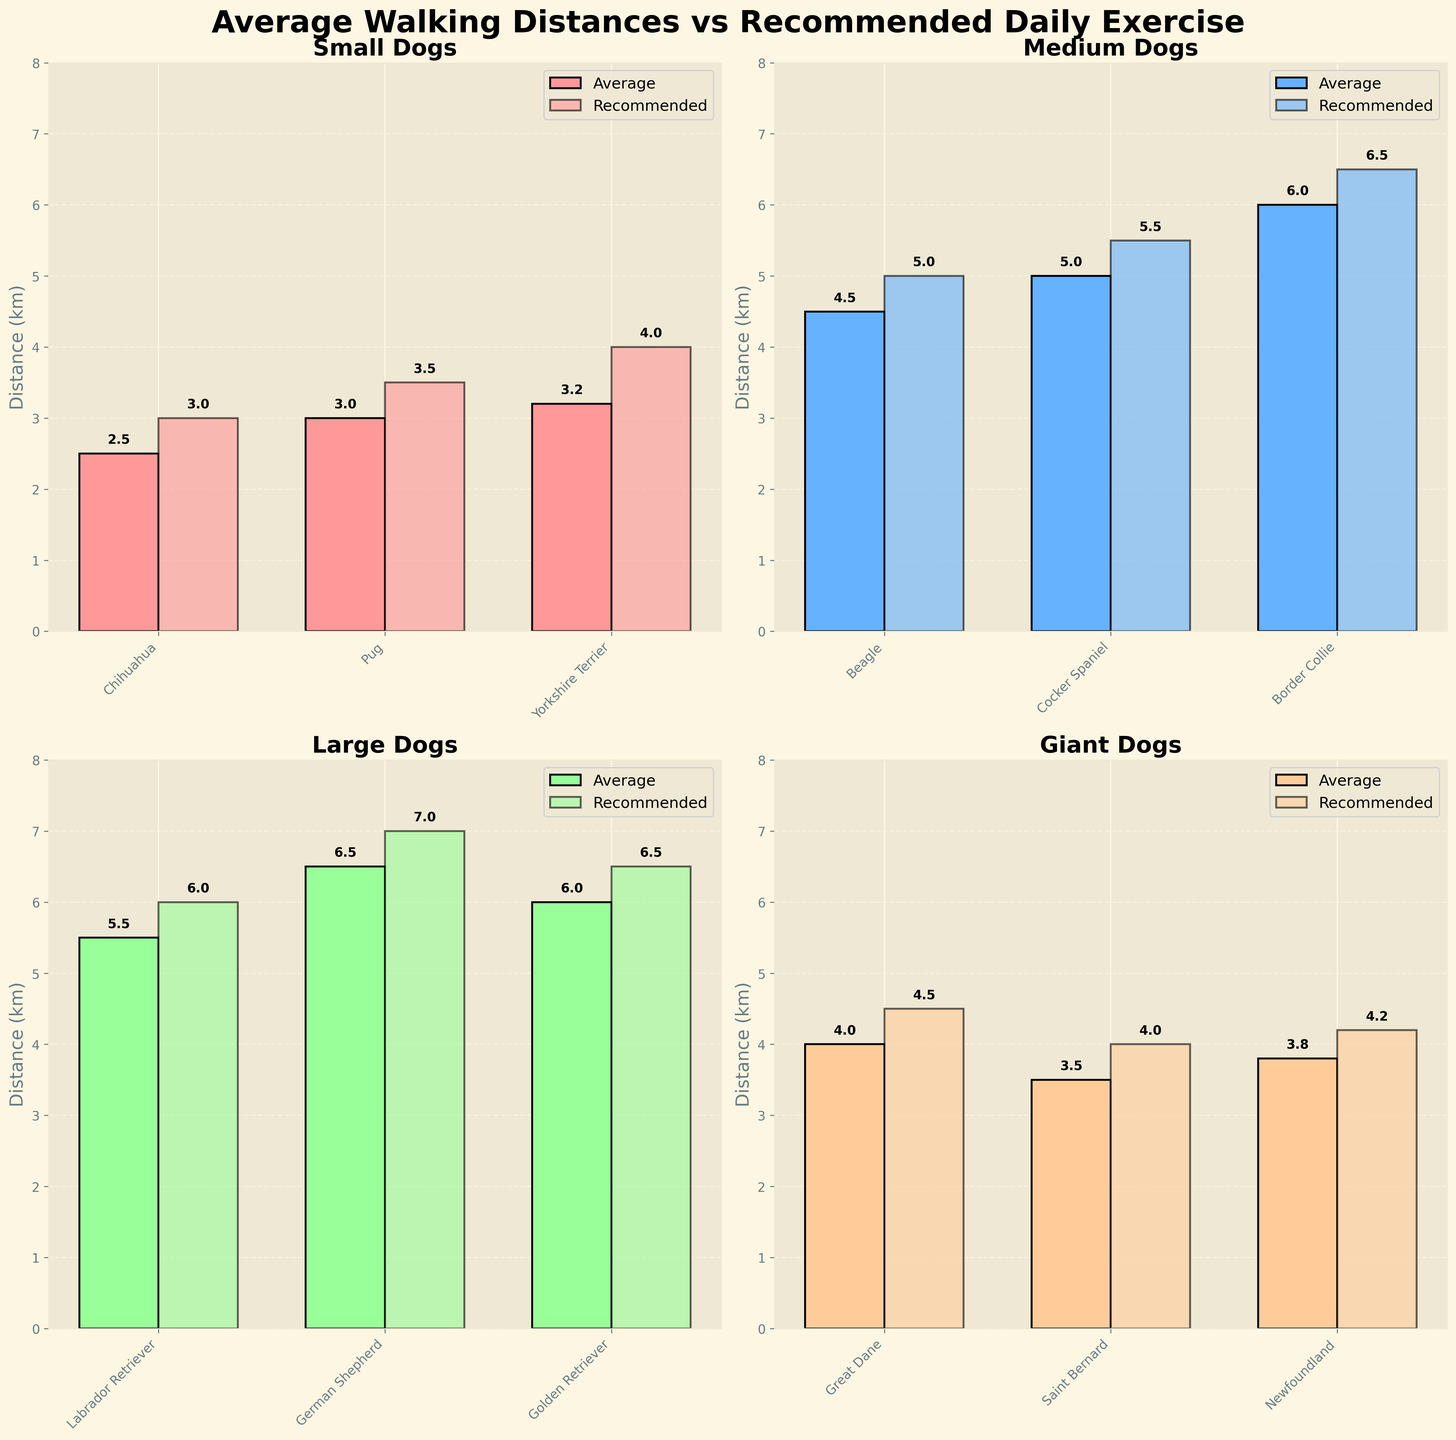What is the average recommended daily exercise for Beagles? Look at the bar labeled "Beagle" under the "Medium Dogs" subplot and find the height of the lighter-colored bar. It shows 5.0 km.
Answer: 5.0 km Which dog breed in the 'Large Dogs' category has the highest average walking distance? Check the 'Large Dogs' subplot. Identify the tallest dark-colored bar, which corresponds to the German Shepherd with a value of 6.5 km.
Answer: German Shepherd How much more daily exercise is recommended for Yorkshire Terriers than for Pugs? In the 'Small Dogs' subplot, compare the lighter-colored bars for Pug and Yorkshire Terrier. The recommended daily exercise for Pug is 3.5 km, and for Yorkshire Terrier, it is 4.0 km. The difference is 4.0 - 3.5 = 0.5 km.
Answer: 0.5 km Is the average walking distance for Labrador Retrievers more or less than the recommended daily exercise? In the 'Large Dogs' subplot, compare the dark-colored bar (average) and the lighter-colored bar (recommended) for Labrador Retriever. The average is 5.5 km, and the recommended is 6.0 km; hence, the average is less.
Answer: Less What is the combined average walking distance for giant breeds? Identify the heights of the dark-colored bars in the 'Giant Dogs' subplot: Great Dane (4.0 km), Saint Bernard (3.5 km), and Newfoundland (3.8 km). Add these values together: 4.0 + 3.5 + 3.8 = 11.3 km.
Answer: 11.3 km Which breed in the 'Small Dogs' category has a greater average walking distance than the recommended daily exercise? Compare the dark-colored (average) and lighter-colored (recommended) bars in the 'Small Dogs' subplot. All dark-colored bars are smaller, so no breed meets this criterion.
Answer: None How much less is the recommended daily exercise for Great Danes compared to German Shepherds? Check the lighter-colored bars for Great Dane (4.5 km) and German Shepherd (7.0 km). Subtract to find the difference: 7.0 - 4.5 = 2.5 km.
Answer: 2.5 km What is the difference between the average walking distances of the breed with the highest and the breed with the lowest average walking distances? The highest average is for German Shepherd (6.5 km) and the lowest is for Saint Bernard (3.5 km). The difference is 6.5 - 3.5 = 3.0 km.
Answer: 3.0 km 